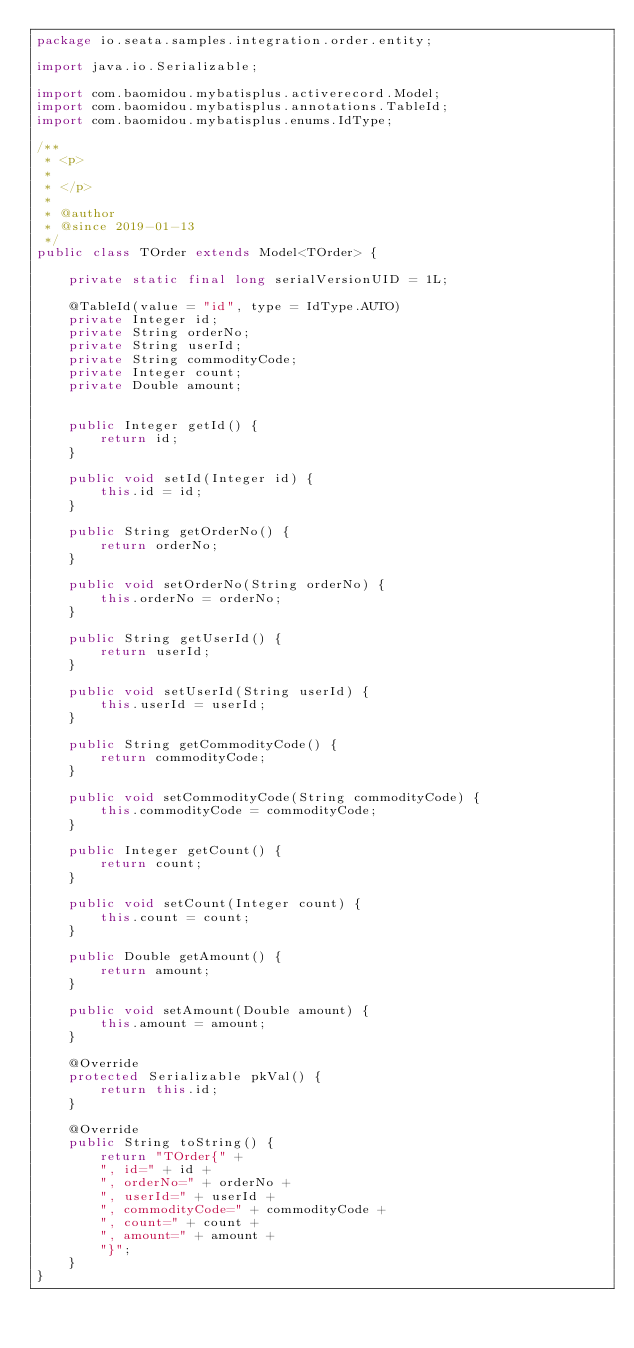<code> <loc_0><loc_0><loc_500><loc_500><_Java_>package io.seata.samples.integration.order.entity;

import java.io.Serializable;

import com.baomidou.mybatisplus.activerecord.Model;
import com.baomidou.mybatisplus.annotations.TableId;
import com.baomidou.mybatisplus.enums.IdType;

/**
 * <p>
 * 
 * </p>
 *
 * @author
 * @since 2019-01-13
 */
public class TOrder extends Model<TOrder> {

    private static final long serialVersionUID = 1L;

    @TableId(value = "id", type = IdType.AUTO)
    private Integer id;
    private String orderNo;
    private String userId;
    private String commodityCode;
    private Integer count;
    private Double amount;


    public Integer getId() {
        return id;
    }

    public void setId(Integer id) {
        this.id = id;
    }

    public String getOrderNo() {
        return orderNo;
    }

    public void setOrderNo(String orderNo) {
        this.orderNo = orderNo;
    }

    public String getUserId() {
        return userId;
    }

    public void setUserId(String userId) {
        this.userId = userId;
    }

    public String getCommodityCode() {
        return commodityCode;
    }

    public void setCommodityCode(String commodityCode) {
        this.commodityCode = commodityCode;
    }

    public Integer getCount() {
        return count;
    }

    public void setCount(Integer count) {
        this.count = count;
    }

    public Double getAmount() {
        return amount;
    }

    public void setAmount(Double amount) {
        this.amount = amount;
    }

    @Override
    protected Serializable pkVal() {
        return this.id;
    }

    @Override
    public String toString() {
        return "TOrder{" +
        ", id=" + id +
        ", orderNo=" + orderNo +
        ", userId=" + userId +
        ", commodityCode=" + commodityCode +
        ", count=" + count +
        ", amount=" + amount +
        "}";
    }
}
</code> 